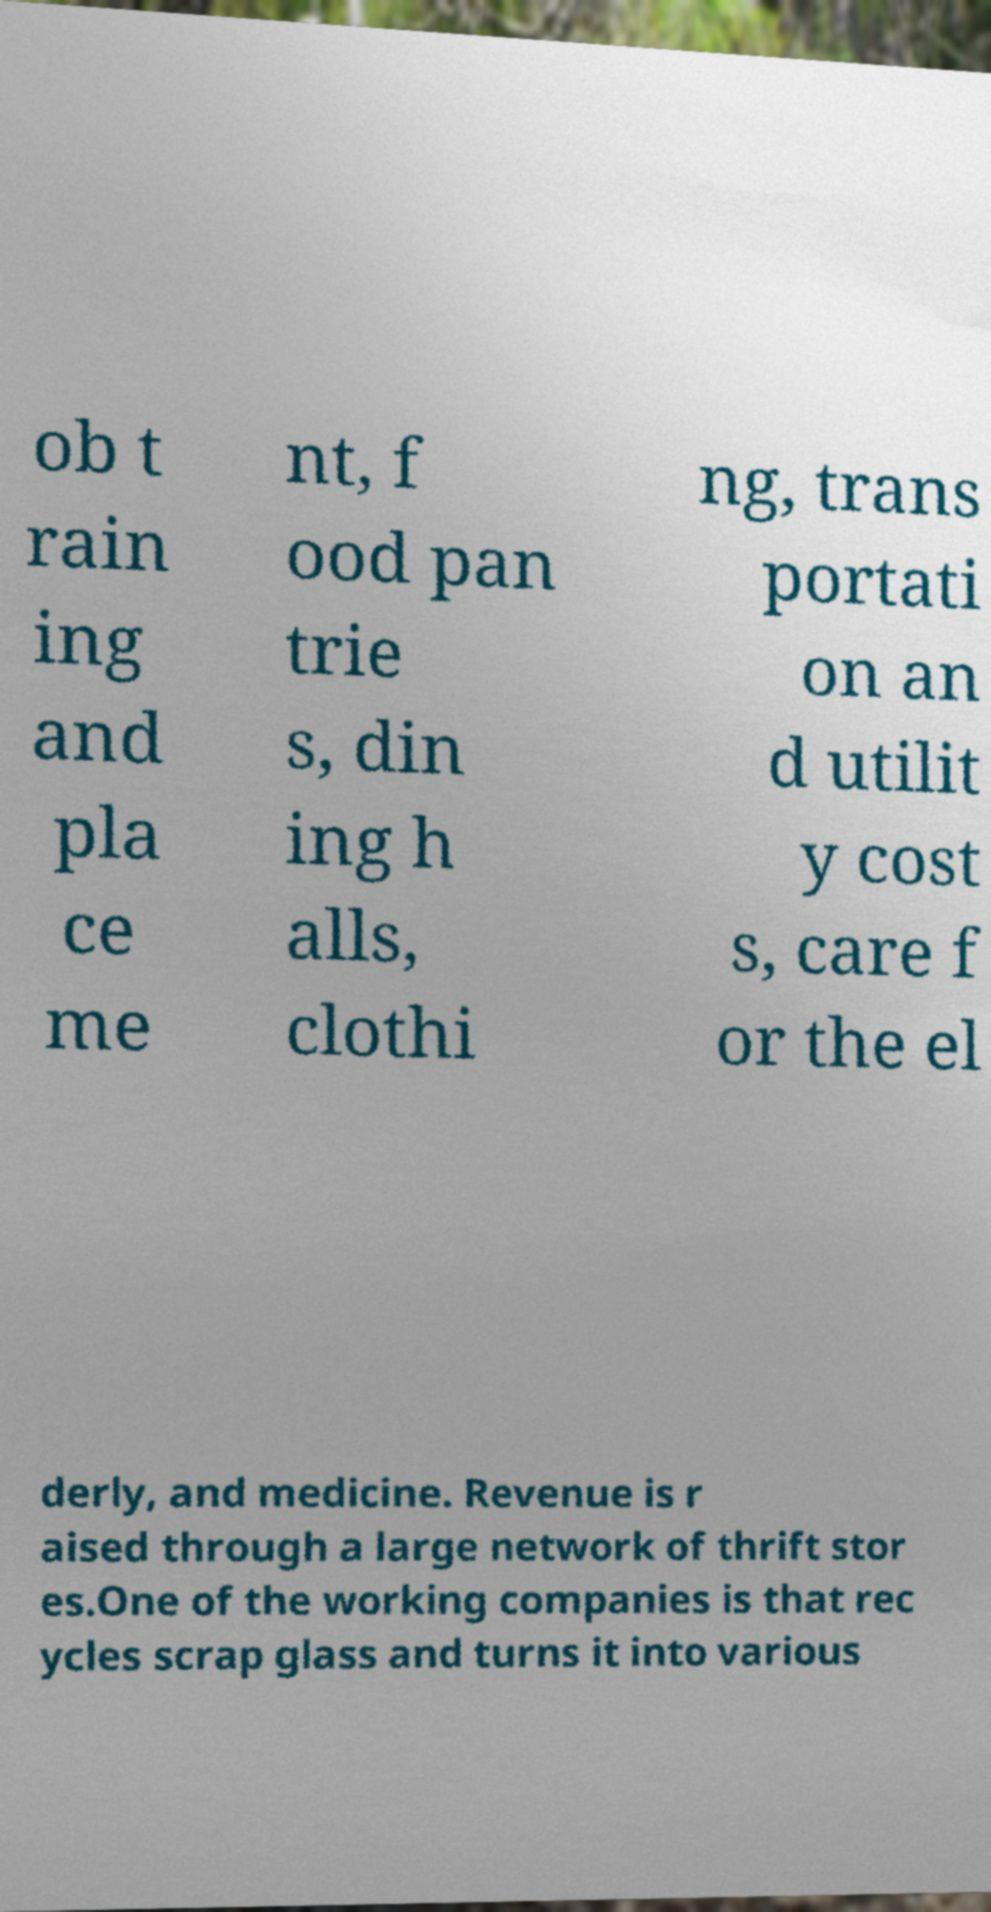Can you read and provide the text displayed in the image?This photo seems to have some interesting text. Can you extract and type it out for me? ob t rain ing and pla ce me nt, f ood pan trie s, din ing h alls, clothi ng, trans portati on an d utilit y cost s, care f or the el derly, and medicine. Revenue is r aised through a large network of thrift stor es.One of the working companies is that rec ycles scrap glass and turns it into various 